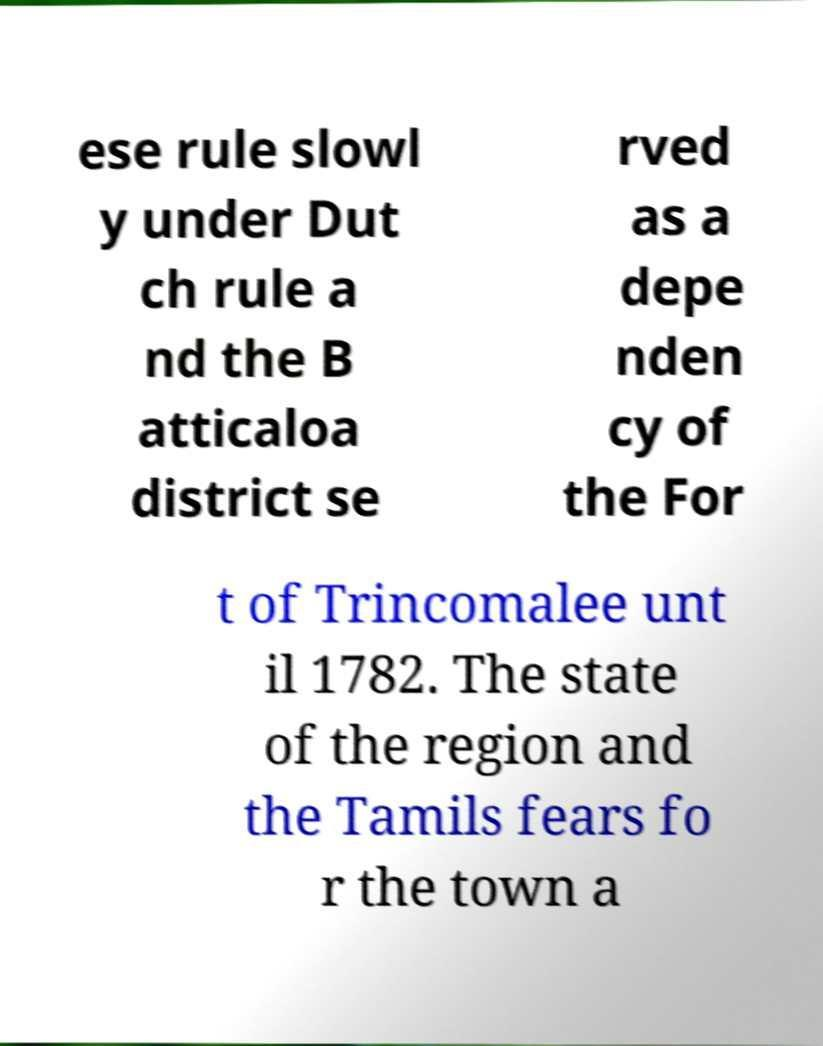Could you assist in decoding the text presented in this image and type it out clearly? ese rule slowl y under Dut ch rule a nd the B atticaloa district se rved as a depe nden cy of the For t of Trincomalee unt il 1782. The state of the region and the Tamils fears fo r the town a 